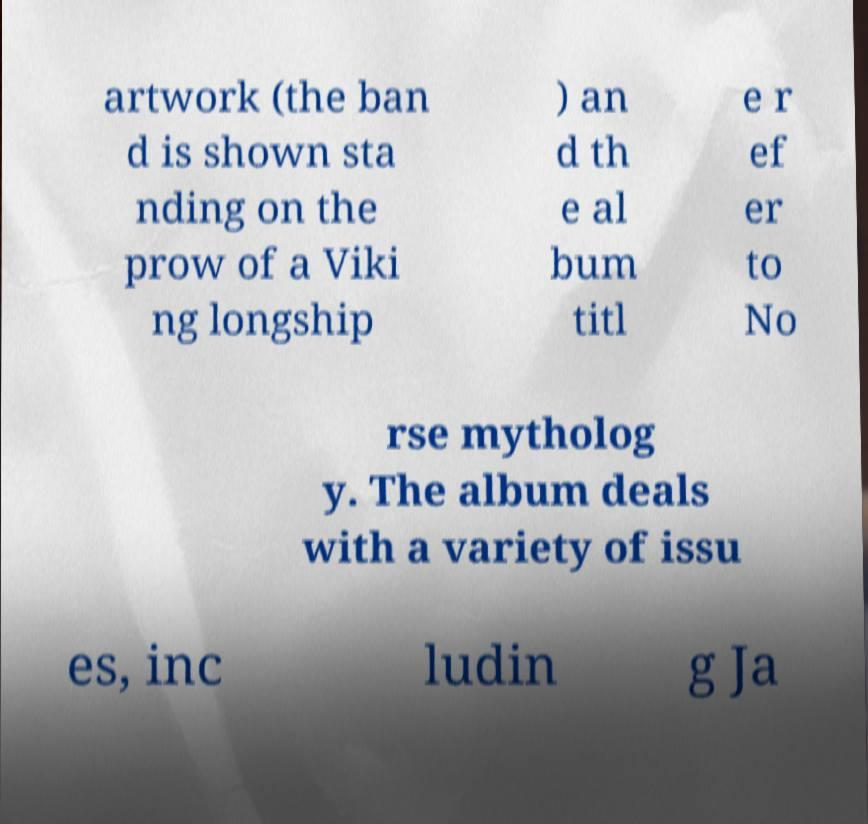Can you read and provide the text displayed in the image?This photo seems to have some interesting text. Can you extract and type it out for me? artwork (the ban d is shown sta nding on the prow of a Viki ng longship ) an d th e al bum titl e r ef er to No rse mytholog y. The album deals with a variety of issu es, inc ludin g Ja 